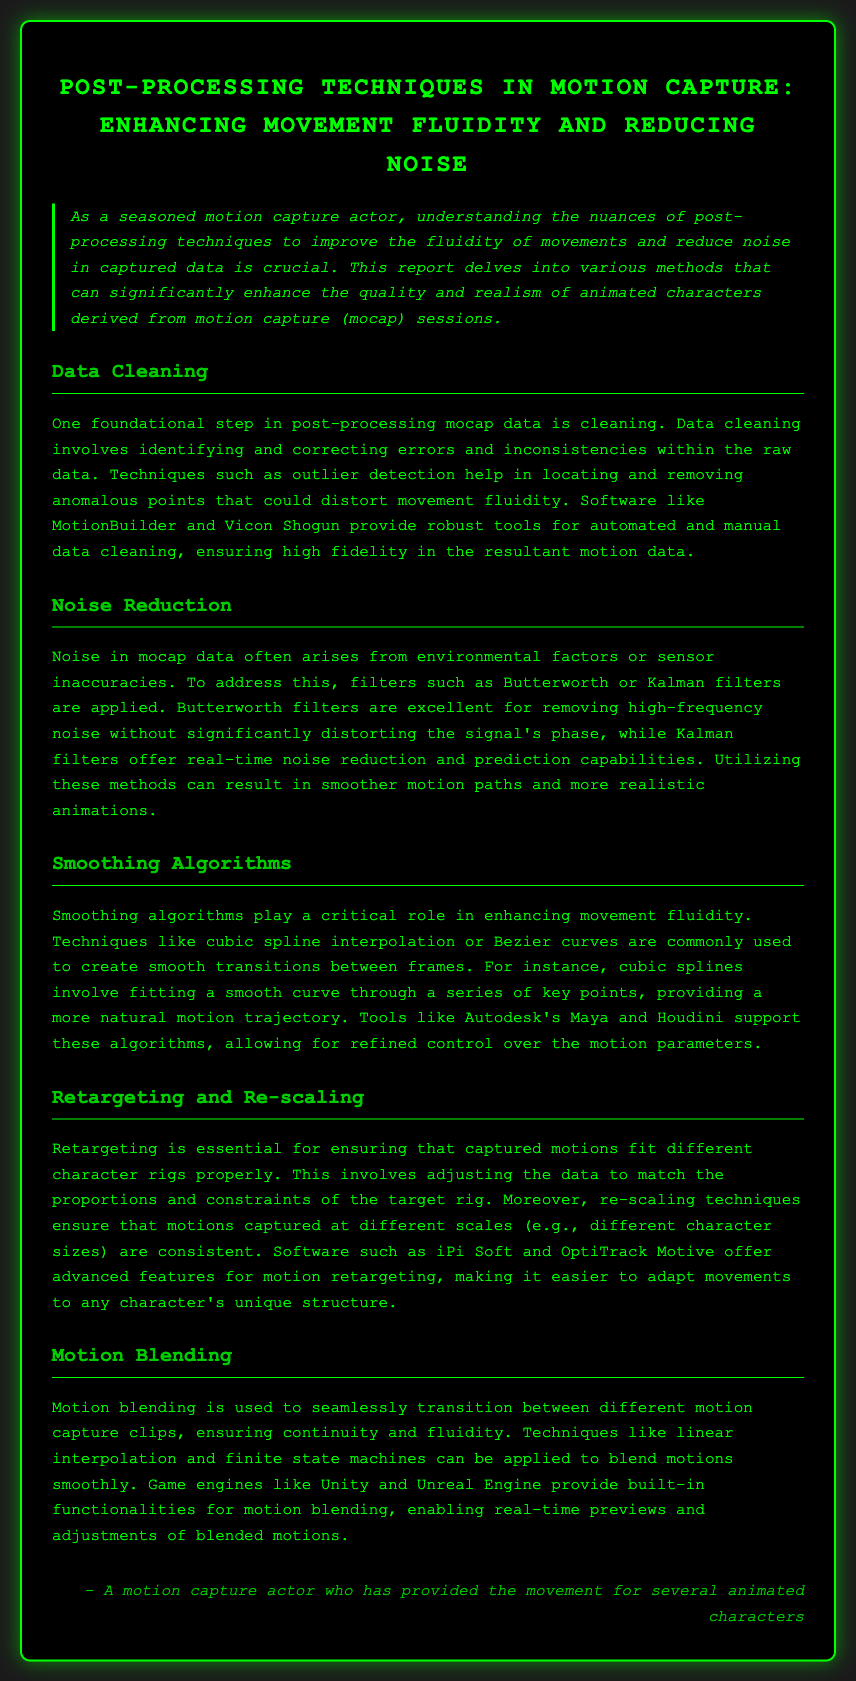What is the title of the report? The title is explicitly mentioned at the beginning of the document, which discusses post-processing techniques in motion capture.
Answer: Post-Processing Techniques in Motion Capture: Enhancing Movement Fluidity and Reducing Noise What is one foundational step in post-processing mocap data? The document identifies data cleaning as a foundational step in the post-processing of motion capture data.
Answer: Data Cleaning What technique is used for removing high-frequency noise? The document states that Butterworth filters are effective in removing high-frequency noise in motion capture data.
Answer: Butterworth filters What is the role of smoothing algorithms in motion capture? The report explains that smoothing algorithms enhance movement fluidity, creating smooth transitions between frames.
Answer: Enhance movement fluidity What software supports cubic spline interpolation? The document mentions Autodesk's Maya and Houdini as tools that support cubic spline interpolation.
Answer: Autodesk Maya and Houdini What is the purpose of motion blending? The document states that motion blending is used to transition seamlessly between different motion capture clips.
Answer: Transition seamlessly What is the primary focus of this lab report? The primary focus is on post-processing techniques that improve motion capture data quality and realism.
Answer: Improve motion capture data quality and realism What is a common method for data cleaning mentioned in the document? The document discusses outlier detection as a common method for cleaning motion capture data.
Answer: Outlier detection 